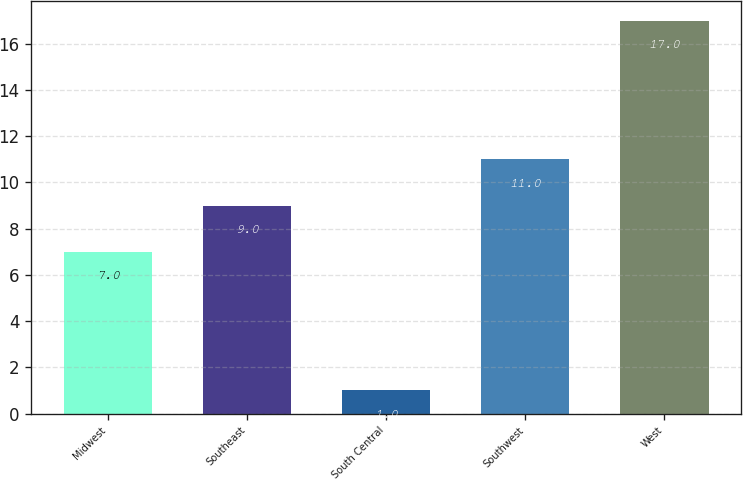Convert chart. <chart><loc_0><loc_0><loc_500><loc_500><bar_chart><fcel>Midwest<fcel>Southeast<fcel>South Central<fcel>Southwest<fcel>West<nl><fcel>7<fcel>9<fcel>1<fcel>11<fcel>17<nl></chart> 